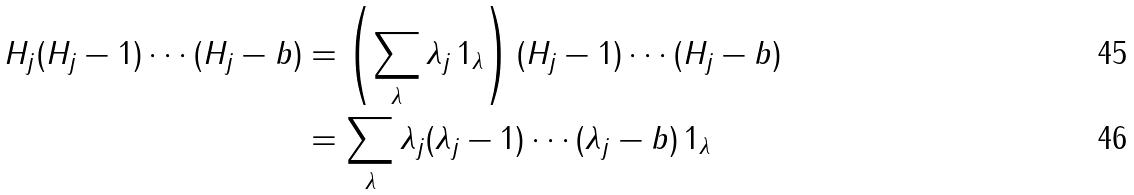<formula> <loc_0><loc_0><loc_500><loc_500>H _ { j } ( H _ { j } - 1 ) \cdots ( H _ { j } - b ) & = \left ( \sum _ { \lambda } \lambda _ { j } \, 1 _ { \lambda } \right ) ( H _ { j } - 1 ) \cdots ( H _ { j } - b ) \\ & = \sum _ { \lambda } \lambda _ { j } ( \lambda _ { j } - 1 ) \cdots ( \lambda _ { j } - b ) \, 1 _ { \lambda }</formula> 